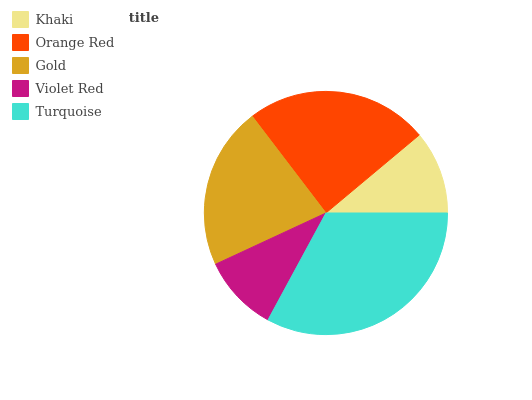Is Violet Red the minimum?
Answer yes or no. Yes. Is Turquoise the maximum?
Answer yes or no. Yes. Is Orange Red the minimum?
Answer yes or no. No. Is Orange Red the maximum?
Answer yes or no. No. Is Orange Red greater than Khaki?
Answer yes or no. Yes. Is Khaki less than Orange Red?
Answer yes or no. Yes. Is Khaki greater than Orange Red?
Answer yes or no. No. Is Orange Red less than Khaki?
Answer yes or no. No. Is Gold the high median?
Answer yes or no. Yes. Is Gold the low median?
Answer yes or no. Yes. Is Turquoise the high median?
Answer yes or no. No. Is Orange Red the low median?
Answer yes or no. No. 